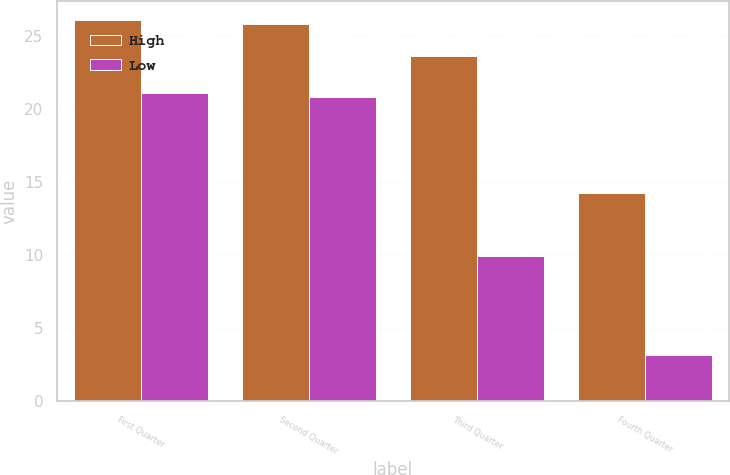Convert chart. <chart><loc_0><loc_0><loc_500><loc_500><stacked_bar_chart><ecel><fcel>First Quarter<fcel>Second Quarter<fcel>Third Quarter<fcel>Fourth Quarter<nl><fcel>High<fcel>26.08<fcel>25.79<fcel>23.63<fcel>14.26<nl><fcel>Low<fcel>21.11<fcel>20.82<fcel>9.92<fcel>3.15<nl></chart> 